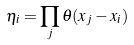Convert formula to latex. <formula><loc_0><loc_0><loc_500><loc_500>\eta _ { i } = \prod _ { j } \theta ( x _ { j } - x _ { i } )</formula> 